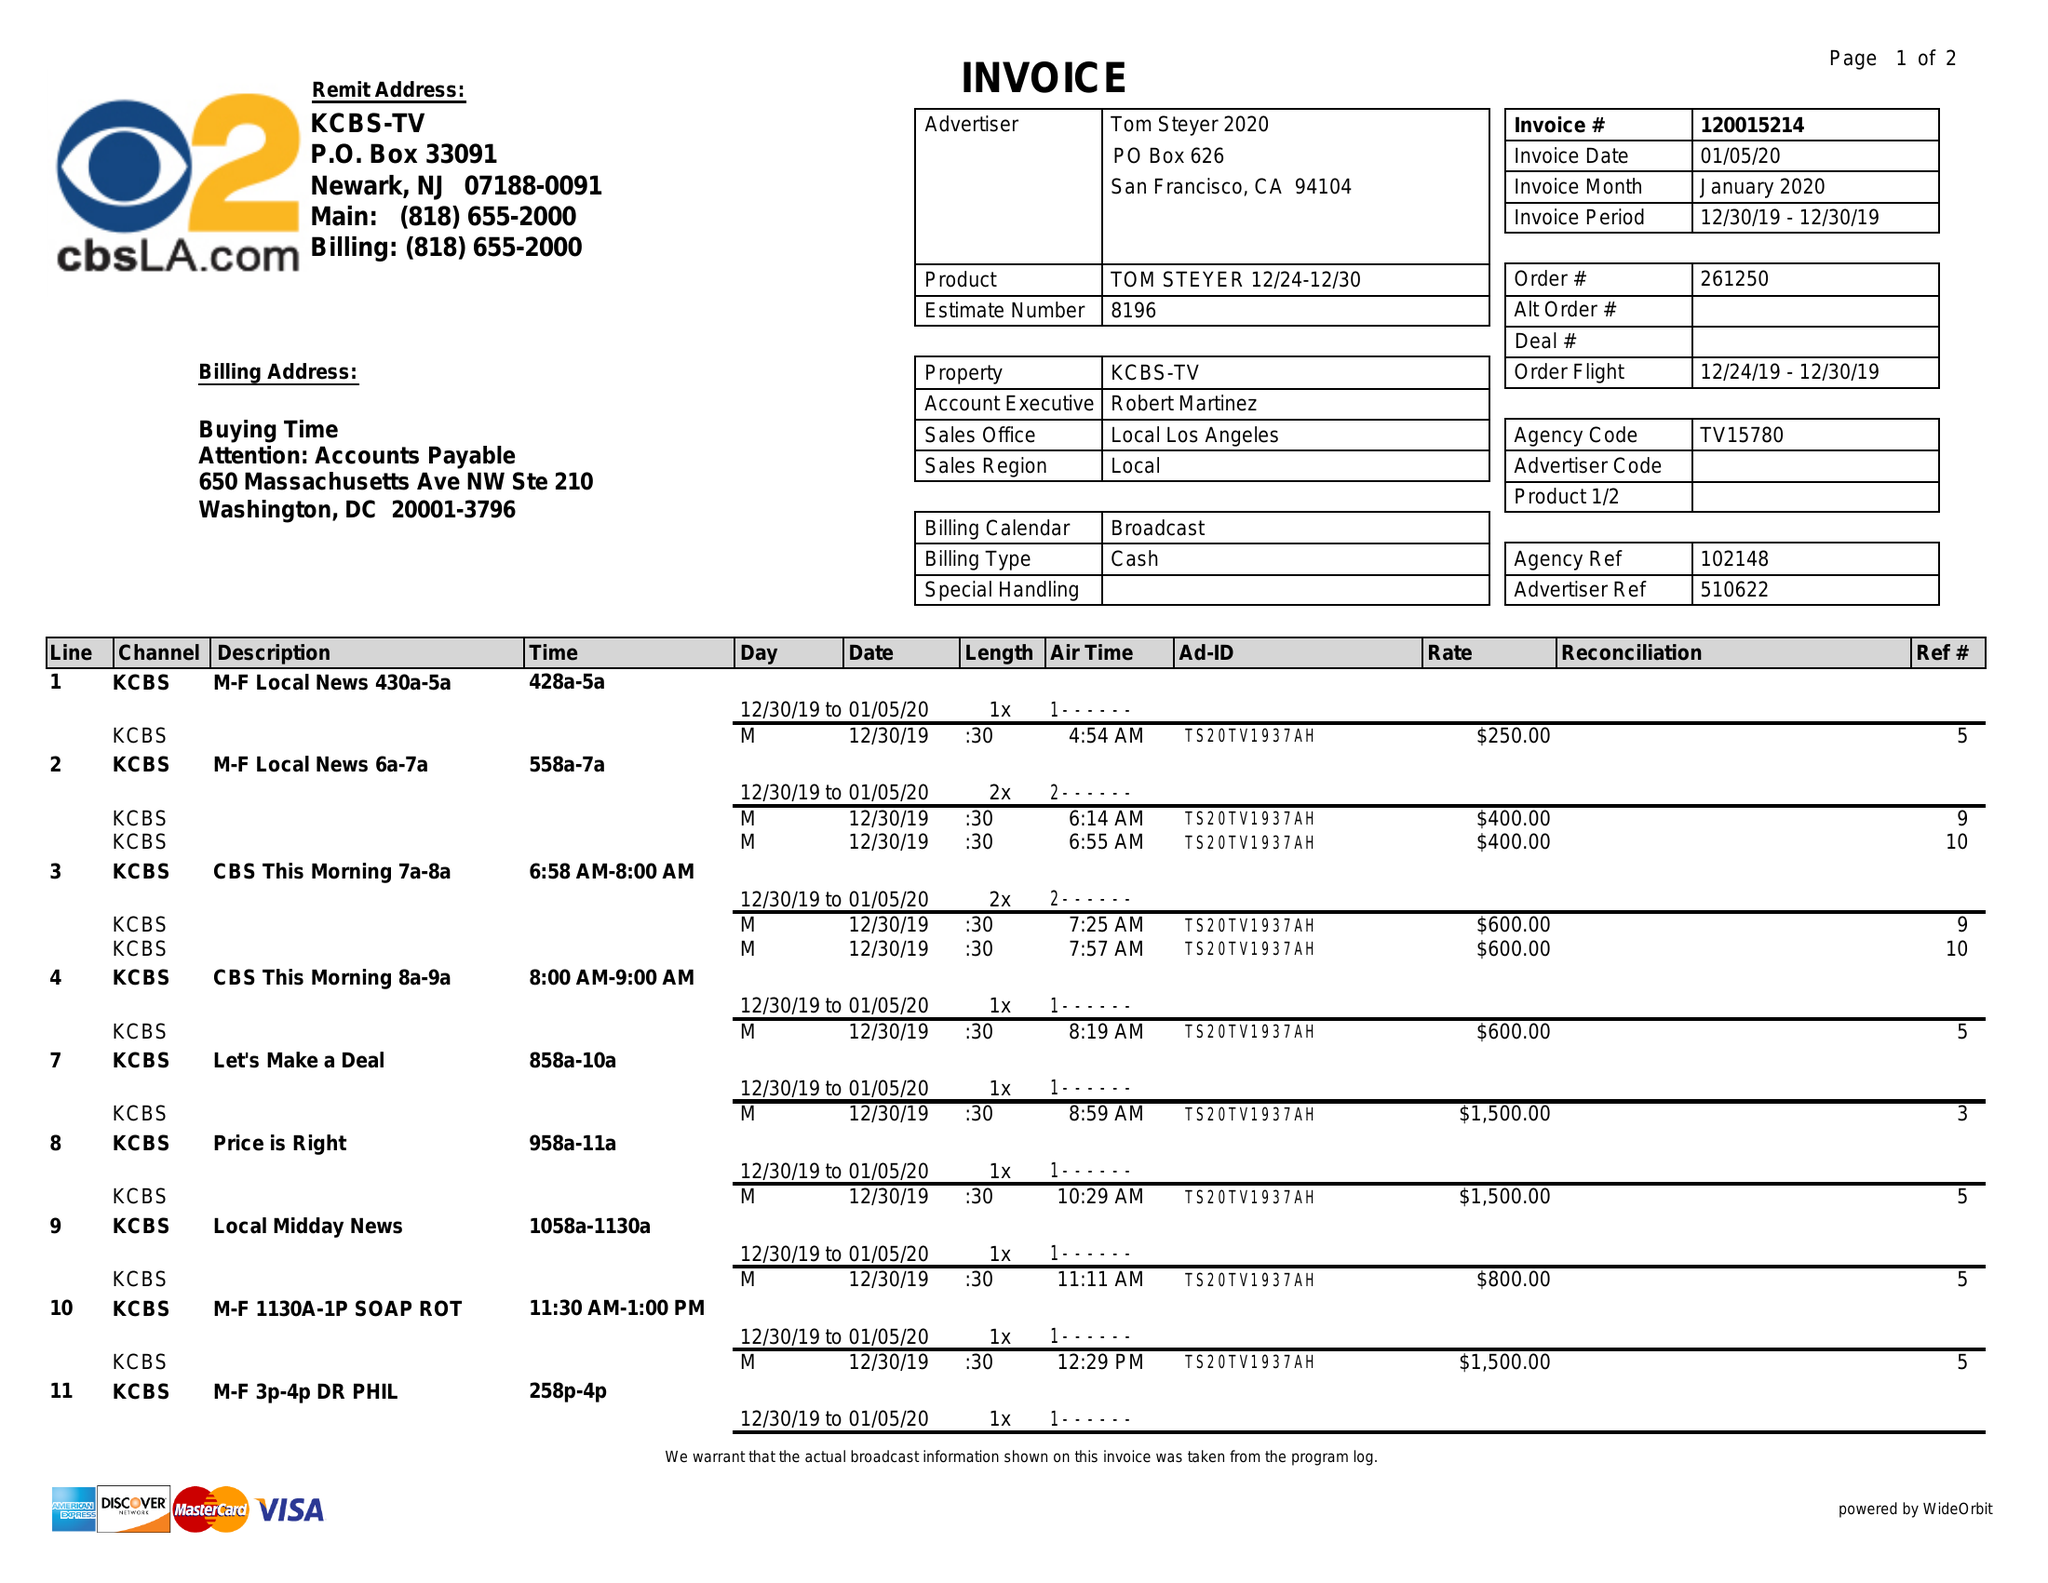What is the value for the flight_to?
Answer the question using a single word or phrase. 12/30/19 